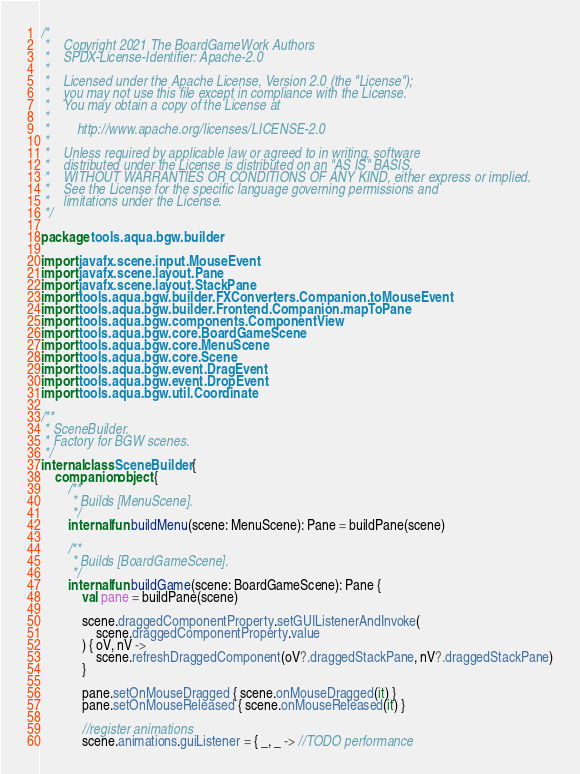<code> <loc_0><loc_0><loc_500><loc_500><_Kotlin_>/*
 *    Copyright 2021 The BoardGameWork Authors
 *    SPDX-License-Identifier: Apache-2.0
 *
 *    Licensed under the Apache License, Version 2.0 (the "License");
 *    you may not use this file except in compliance with the License.
 *    You may obtain a copy of the License at
 *
 *        http://www.apache.org/licenses/LICENSE-2.0
 *
 *    Unless required by applicable law or agreed to in writing, software
 *    distributed under the License is distributed on an "AS IS" BASIS,
 *    WITHOUT WARRANTIES OR CONDITIONS OF ANY KIND, either express or implied.
 *    See the License for the specific language governing permissions and
 *    limitations under the License.
 */

package tools.aqua.bgw.builder

import javafx.scene.input.MouseEvent
import javafx.scene.layout.Pane
import javafx.scene.layout.StackPane
import tools.aqua.bgw.builder.FXConverters.Companion.toMouseEvent
import tools.aqua.bgw.builder.Frontend.Companion.mapToPane
import tools.aqua.bgw.components.ComponentView
import tools.aqua.bgw.core.BoardGameScene
import tools.aqua.bgw.core.MenuScene
import tools.aqua.bgw.core.Scene
import tools.aqua.bgw.event.DragEvent
import tools.aqua.bgw.event.DropEvent
import tools.aqua.bgw.util.Coordinate

/**
 * SceneBuilder.
 * Factory for BGW scenes.
 */
internal class SceneBuilder {
	companion object {
		/**
		 * Builds [MenuScene].
		 */
		internal fun buildMenu(scene: MenuScene): Pane = buildPane(scene)
		
		/**
		 * Builds [BoardGameScene].
		 */
		internal fun buildGame(scene: BoardGameScene): Pane {
			val pane = buildPane(scene)
			
			scene.draggedComponentProperty.setGUIListenerAndInvoke(
				scene.draggedComponentProperty.value
			) { oV, nV ->
				scene.refreshDraggedComponent(oV?.draggedStackPane, nV?.draggedStackPane)
			}
			
			pane.setOnMouseDragged { scene.onMouseDragged(it) }
			pane.setOnMouseReleased { scene.onMouseReleased(it) }
			
			//register animations
			scene.animations.guiListener = { _, _ -> //TODO performance</code> 